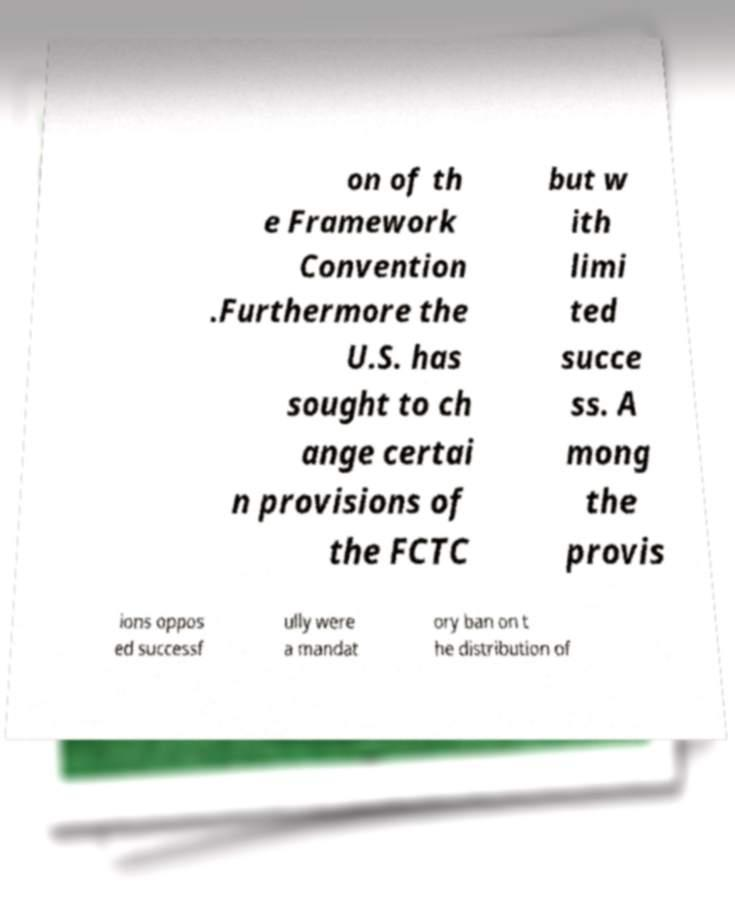What messages or text are displayed in this image? I need them in a readable, typed format. on of th e Framework Convention .Furthermore the U.S. has sought to ch ange certai n provisions of the FCTC but w ith limi ted succe ss. A mong the provis ions oppos ed successf ully were a mandat ory ban on t he distribution of 